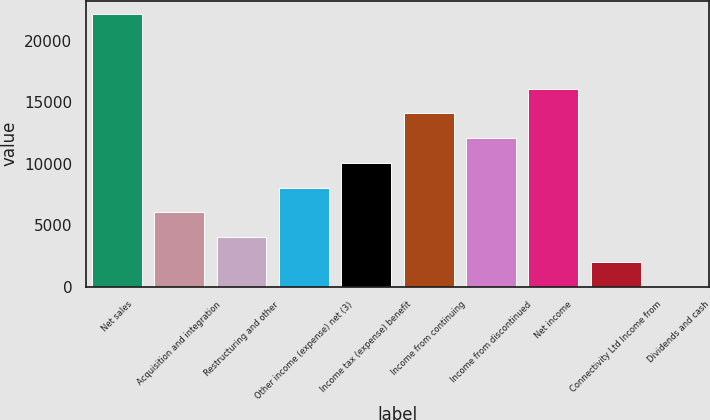<chart> <loc_0><loc_0><loc_500><loc_500><bar_chart><fcel>Net sales<fcel>Acquisition and integration<fcel>Restructuring and other<fcel>Other income (expense) net (3)<fcel>Income tax (expense) benefit<fcel>Income from continuing<fcel>Income from discontinued<fcel>Net income<fcel>Connectivity Ltd Income from<fcel>Dividends and cash<nl><fcel>22145.1<fcel>6040.35<fcel>4027.26<fcel>8053.44<fcel>10066.5<fcel>14092.7<fcel>12079.6<fcel>16105.8<fcel>2014.17<fcel>1.08<nl></chart> 